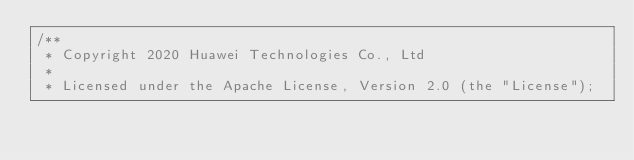<code> <loc_0><loc_0><loc_500><loc_500><_Cuda_>/**
 * Copyright 2020 Huawei Technologies Co., Ltd
 *
 * Licensed under the Apache License, Version 2.0 (the "License");</code> 